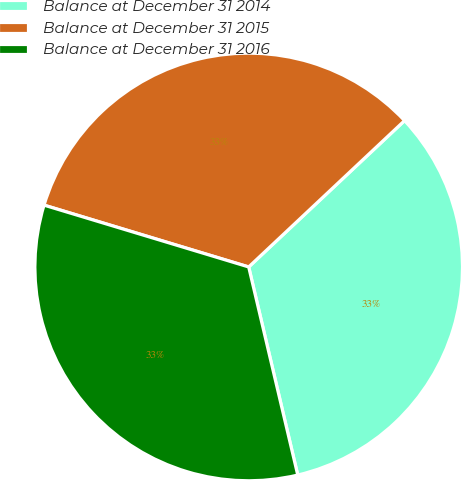<chart> <loc_0><loc_0><loc_500><loc_500><pie_chart><fcel>Balance at December 31 2014<fcel>Balance at December 31 2015<fcel>Balance at December 31 2016<nl><fcel>33.31%<fcel>33.33%<fcel>33.35%<nl></chart> 